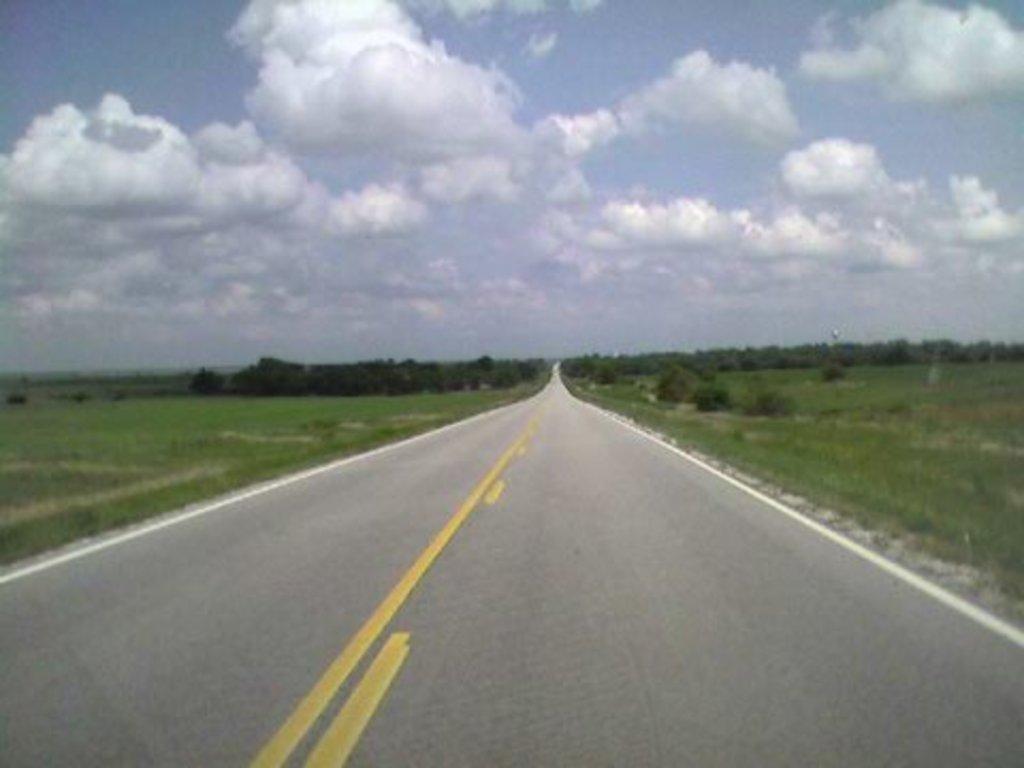Please provide a concise description of this image. This is the road with the margins. Here is the grass. I can see the trees and small bushes. These are the clouds in the sky. 